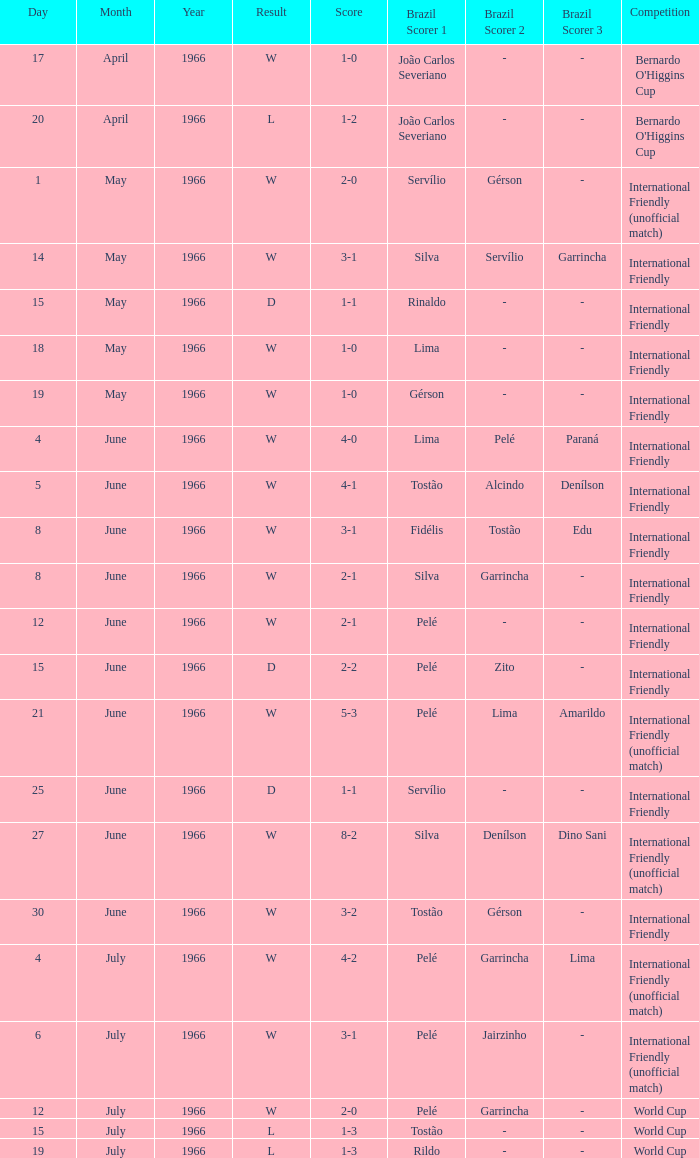What competition has a result of W on June 30, 1966? International Friendly. Help me parse the entirety of this table. {'header': ['Day', 'Month', 'Year', 'Result', 'Score', 'Brazil Scorer 1', 'Brazil Scorer 2', 'Brazil Scorer 3', 'Competition'], 'rows': [['17', 'April', '1966', 'W', '1-0', 'João Carlos Severiano', '-', '-', "Bernardo O'Higgins Cup"], ['20', 'April', '1966', 'L', '1-2', 'João Carlos Severiano', '-', '-', "Bernardo O'Higgins Cup"], ['1', 'May', '1966', 'W', '2-0', 'Servílio', 'Gérson', '-', 'International Friendly (unofficial match)'], ['14', 'May', '1966', 'W', '3-1', 'Silva', 'Servílio', 'Garrincha', 'International Friendly'], ['15', 'May', '1966', 'D', '1-1', 'Rinaldo', '-', '-', 'International Friendly'], ['18', 'May', '1966', 'W', '1-0', 'Lima', '-', '-', 'International Friendly'], ['19', 'May', '1966', 'W', '1-0', 'Gérson', '-', '-', 'International Friendly'], ['4', 'June', '1966', 'W', '4-0', 'Lima', 'Pelé', 'Paraná', 'International Friendly'], ['5', 'June', '1966', 'W', '4-1', 'Tostão', 'Alcindo', 'Denílson', 'International Friendly'], ['8', 'June', '1966', 'W', '3-1', 'Fidélis', 'Tostão', 'Edu', 'International Friendly'], ['8', 'June', '1966', 'W', '2-1', 'Silva', 'Garrincha', '-', 'International Friendly'], ['12', 'June', '1966', 'W', '2-1', 'Pelé', '-', '-', 'International Friendly'], ['15', 'June', '1966', 'D', '2-2', 'Pelé', 'Zito', '-', 'International Friendly'], ['21', 'June', '1966', 'W', '5-3', 'Pelé', 'Lima', 'Amarildo', 'International Friendly (unofficial match)'], ['25', 'June', '1966', 'D', '1-1', 'Servílio', '-', '-', 'International Friendly'], ['27', 'June', '1966', 'W', '8-2', 'Silva', 'Denílson', 'Dino Sani', 'International Friendly (unofficial match)'], ['30', 'June', '1966', 'W', '3-2', 'Tostão', 'Gérson', '-', 'International Friendly'], ['4', 'July', '1966', 'W', '4-2', 'Pelé', 'Garrincha', 'Lima', 'International Friendly (unofficial match)'], ['6', 'July', '1966', 'W', '3-1', 'Pelé', 'Jairzinho', '-', 'International Friendly (unofficial match)'], ['12', 'July', '1966', 'W', '2-0', 'Pelé', 'Garrincha', '-', 'World Cup'], ['15', 'July', '1966', 'L', '1-3', 'Tostão', '-', '-', 'World Cup'], ['19', 'July', '1966', 'L', '1-3', 'Rildo', '-', '-', 'World Cup']]} 